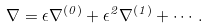Convert formula to latex. <formula><loc_0><loc_0><loc_500><loc_500>\nabla = \epsilon \nabla ^ { ( 0 ) } + \epsilon ^ { 2 } \nabla ^ { ( 1 ) } + \cdots .</formula> 